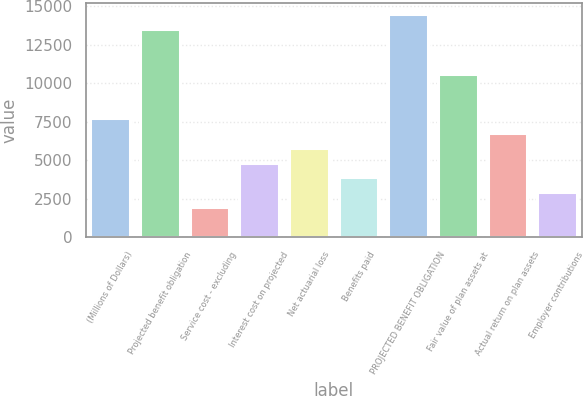Convert chart to OTSL. <chart><loc_0><loc_0><loc_500><loc_500><bar_chart><fcel>(Millions of Dollars)<fcel>Projected benefit obligation<fcel>Service cost - excluding<fcel>Interest cost on projected<fcel>Net actuarial loss<fcel>Benefits paid<fcel>PROJECTED BENEFIT OBLIGATION<fcel>Fair value of plan assets at<fcel>Actual return on plan assets<fcel>Employer contributions<nl><fcel>7726.8<fcel>13505.4<fcel>1948.2<fcel>4837.5<fcel>5800.6<fcel>3874.4<fcel>14468.5<fcel>10616.1<fcel>6763.7<fcel>2911.3<nl></chart> 